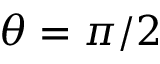<formula> <loc_0><loc_0><loc_500><loc_500>\theta = \pi / 2</formula> 